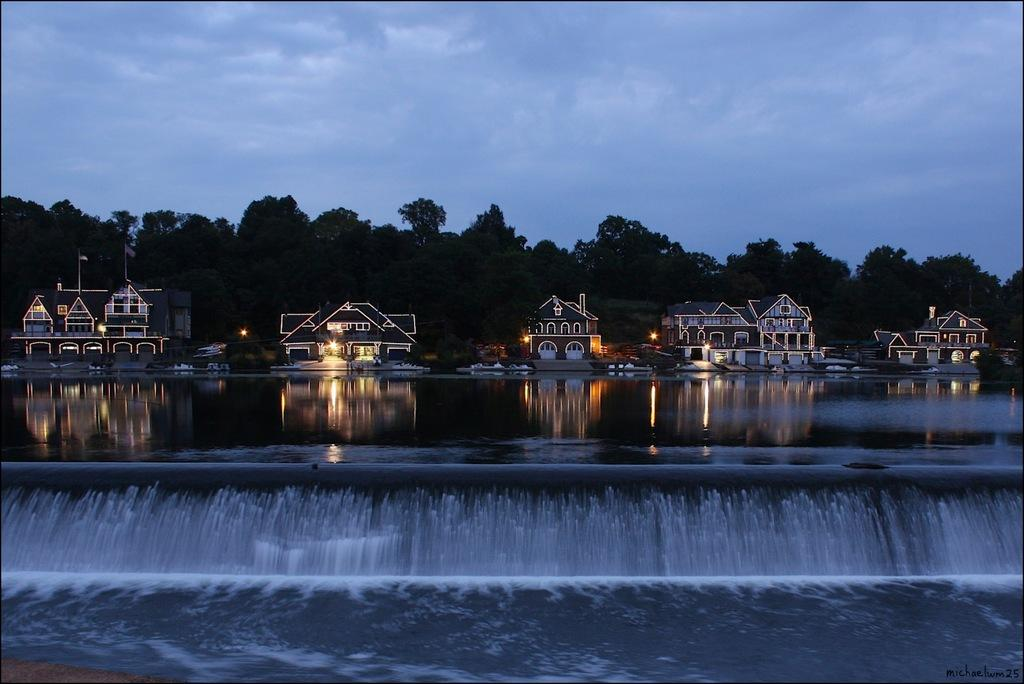What can be seen in the water in the image? There are waves in the water in the image. What structures are visible in the image? There are buildings in the image. How are the buildings illuminated? The buildings have lights. What type of vegetation is behind the buildings? There are trees behind the buildings. What is the condition of the sky in the image? The sky is cloudy in the image. What type of toys can be seen on the trees behind the buildings? There are no toys present in the image; it features trees behind the buildings. What kind of fruit is hanging from the lights on the buildings? There is no fruit hanging from the lights on the buildings; the buildings have lights for illumination. 